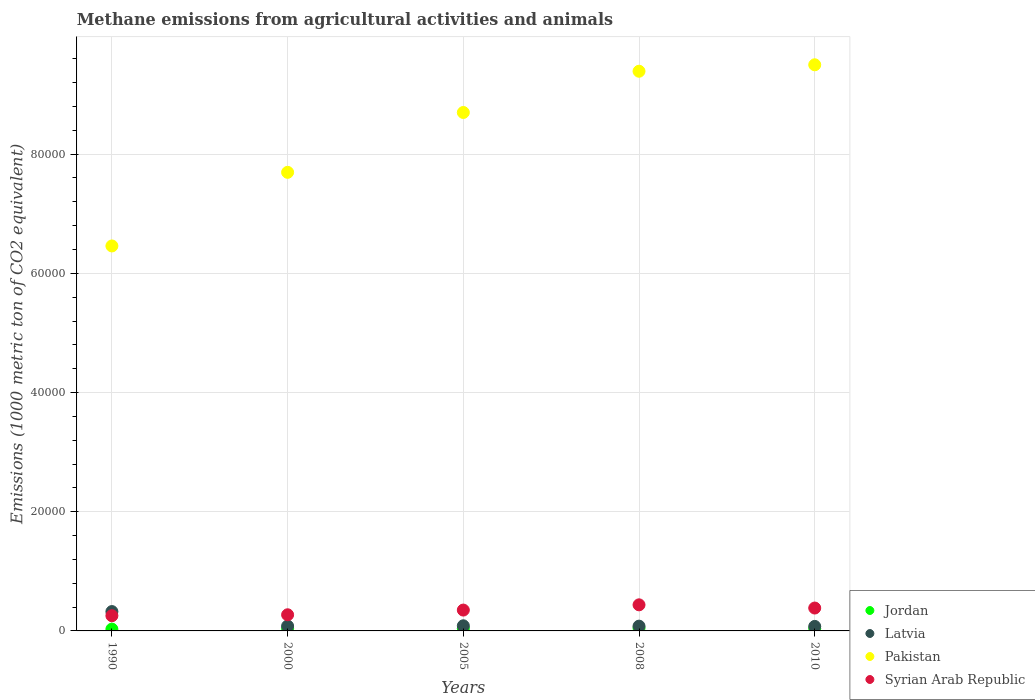How many different coloured dotlines are there?
Offer a terse response. 4. Is the number of dotlines equal to the number of legend labels?
Provide a short and direct response. Yes. What is the amount of methane emitted in Pakistan in 1990?
Your answer should be very brief. 6.46e+04. Across all years, what is the maximum amount of methane emitted in Latvia?
Your answer should be compact. 3247.8. Across all years, what is the minimum amount of methane emitted in Syrian Arab Republic?
Your response must be concise. 2551.7. In which year was the amount of methane emitted in Syrian Arab Republic maximum?
Offer a terse response. 2008. In which year was the amount of methane emitted in Pakistan minimum?
Your answer should be very brief. 1990. What is the total amount of methane emitted in Latvia in the graph?
Your answer should be compact. 6479.7. What is the difference between the amount of methane emitted in Latvia in 1990 and that in 2010?
Your response must be concise. 2491.9. What is the difference between the amount of methane emitted in Jordan in 2000 and the amount of methane emitted in Pakistan in 2010?
Make the answer very short. -9.46e+04. What is the average amount of methane emitted in Syrian Arab Republic per year?
Your answer should be compact. 3395.08. In the year 2010, what is the difference between the amount of methane emitted in Latvia and amount of methane emitted in Jordan?
Your answer should be compact. 358.3. What is the ratio of the amount of methane emitted in Syrian Arab Republic in 1990 to that in 2010?
Your answer should be very brief. 0.66. Is the amount of methane emitted in Pakistan in 2005 less than that in 2008?
Give a very brief answer. Yes. What is the difference between the highest and the second highest amount of methane emitted in Pakistan?
Keep it short and to the point. 1082. What is the difference between the highest and the lowest amount of methane emitted in Jordan?
Make the answer very short. 167.1. In how many years, is the amount of methane emitted in Latvia greater than the average amount of methane emitted in Latvia taken over all years?
Offer a very short reply. 1. Is the sum of the amount of methane emitted in Jordan in 2005 and 2008 greater than the maximum amount of methane emitted in Syrian Arab Republic across all years?
Your response must be concise. No. Is it the case that in every year, the sum of the amount of methane emitted in Syrian Arab Republic and amount of methane emitted in Latvia  is greater than the sum of amount of methane emitted in Jordan and amount of methane emitted in Pakistan?
Offer a very short reply. Yes. Does the amount of methane emitted in Latvia monotonically increase over the years?
Your answer should be compact. No. How many dotlines are there?
Offer a terse response. 4. Are the values on the major ticks of Y-axis written in scientific E-notation?
Provide a short and direct response. No. Does the graph contain grids?
Offer a terse response. Yes. How many legend labels are there?
Provide a succinct answer. 4. What is the title of the graph?
Your response must be concise. Methane emissions from agricultural activities and animals. Does "Uganda" appear as one of the legend labels in the graph?
Make the answer very short. No. What is the label or title of the X-axis?
Your response must be concise. Years. What is the label or title of the Y-axis?
Give a very brief answer. Emissions (1000 metric ton of CO2 equivalent). What is the Emissions (1000 metric ton of CO2 equivalent) of Jordan in 1990?
Ensure brevity in your answer.  303.3. What is the Emissions (1000 metric ton of CO2 equivalent) in Latvia in 1990?
Your response must be concise. 3247.8. What is the Emissions (1000 metric ton of CO2 equivalent) in Pakistan in 1990?
Offer a very short reply. 6.46e+04. What is the Emissions (1000 metric ton of CO2 equivalent) in Syrian Arab Republic in 1990?
Provide a succinct answer. 2551.7. What is the Emissions (1000 metric ton of CO2 equivalent) in Jordan in 2000?
Provide a succinct answer. 374. What is the Emissions (1000 metric ton of CO2 equivalent) of Latvia in 2000?
Make the answer very short. 814.5. What is the Emissions (1000 metric ton of CO2 equivalent) in Pakistan in 2000?
Ensure brevity in your answer.  7.69e+04. What is the Emissions (1000 metric ton of CO2 equivalent) in Syrian Arab Republic in 2000?
Ensure brevity in your answer.  2708.8. What is the Emissions (1000 metric ton of CO2 equivalent) in Jordan in 2005?
Your answer should be very brief. 391.8. What is the Emissions (1000 metric ton of CO2 equivalent) in Latvia in 2005?
Ensure brevity in your answer.  860.7. What is the Emissions (1000 metric ton of CO2 equivalent) in Pakistan in 2005?
Ensure brevity in your answer.  8.70e+04. What is the Emissions (1000 metric ton of CO2 equivalent) of Syrian Arab Republic in 2005?
Offer a terse response. 3498.3. What is the Emissions (1000 metric ton of CO2 equivalent) of Jordan in 2008?
Provide a succinct answer. 470.4. What is the Emissions (1000 metric ton of CO2 equivalent) of Latvia in 2008?
Your answer should be compact. 800.8. What is the Emissions (1000 metric ton of CO2 equivalent) of Pakistan in 2008?
Keep it short and to the point. 9.39e+04. What is the Emissions (1000 metric ton of CO2 equivalent) in Syrian Arab Republic in 2008?
Make the answer very short. 4376.8. What is the Emissions (1000 metric ton of CO2 equivalent) of Jordan in 2010?
Offer a very short reply. 397.6. What is the Emissions (1000 metric ton of CO2 equivalent) in Latvia in 2010?
Your response must be concise. 755.9. What is the Emissions (1000 metric ton of CO2 equivalent) of Pakistan in 2010?
Ensure brevity in your answer.  9.50e+04. What is the Emissions (1000 metric ton of CO2 equivalent) of Syrian Arab Republic in 2010?
Provide a succinct answer. 3839.8. Across all years, what is the maximum Emissions (1000 metric ton of CO2 equivalent) of Jordan?
Your answer should be compact. 470.4. Across all years, what is the maximum Emissions (1000 metric ton of CO2 equivalent) of Latvia?
Your response must be concise. 3247.8. Across all years, what is the maximum Emissions (1000 metric ton of CO2 equivalent) of Pakistan?
Keep it short and to the point. 9.50e+04. Across all years, what is the maximum Emissions (1000 metric ton of CO2 equivalent) in Syrian Arab Republic?
Offer a terse response. 4376.8. Across all years, what is the minimum Emissions (1000 metric ton of CO2 equivalent) of Jordan?
Your response must be concise. 303.3. Across all years, what is the minimum Emissions (1000 metric ton of CO2 equivalent) of Latvia?
Ensure brevity in your answer.  755.9. Across all years, what is the minimum Emissions (1000 metric ton of CO2 equivalent) in Pakistan?
Your response must be concise. 6.46e+04. Across all years, what is the minimum Emissions (1000 metric ton of CO2 equivalent) in Syrian Arab Republic?
Your response must be concise. 2551.7. What is the total Emissions (1000 metric ton of CO2 equivalent) in Jordan in the graph?
Your answer should be very brief. 1937.1. What is the total Emissions (1000 metric ton of CO2 equivalent) in Latvia in the graph?
Your answer should be very brief. 6479.7. What is the total Emissions (1000 metric ton of CO2 equivalent) in Pakistan in the graph?
Give a very brief answer. 4.17e+05. What is the total Emissions (1000 metric ton of CO2 equivalent) in Syrian Arab Republic in the graph?
Your answer should be compact. 1.70e+04. What is the difference between the Emissions (1000 metric ton of CO2 equivalent) of Jordan in 1990 and that in 2000?
Offer a very short reply. -70.7. What is the difference between the Emissions (1000 metric ton of CO2 equivalent) of Latvia in 1990 and that in 2000?
Provide a succinct answer. 2433.3. What is the difference between the Emissions (1000 metric ton of CO2 equivalent) of Pakistan in 1990 and that in 2000?
Your answer should be compact. -1.24e+04. What is the difference between the Emissions (1000 metric ton of CO2 equivalent) of Syrian Arab Republic in 1990 and that in 2000?
Provide a short and direct response. -157.1. What is the difference between the Emissions (1000 metric ton of CO2 equivalent) in Jordan in 1990 and that in 2005?
Provide a succinct answer. -88.5. What is the difference between the Emissions (1000 metric ton of CO2 equivalent) of Latvia in 1990 and that in 2005?
Give a very brief answer. 2387.1. What is the difference between the Emissions (1000 metric ton of CO2 equivalent) of Pakistan in 1990 and that in 2005?
Make the answer very short. -2.24e+04. What is the difference between the Emissions (1000 metric ton of CO2 equivalent) in Syrian Arab Republic in 1990 and that in 2005?
Provide a succinct answer. -946.6. What is the difference between the Emissions (1000 metric ton of CO2 equivalent) of Jordan in 1990 and that in 2008?
Offer a very short reply. -167.1. What is the difference between the Emissions (1000 metric ton of CO2 equivalent) of Latvia in 1990 and that in 2008?
Provide a short and direct response. 2447. What is the difference between the Emissions (1000 metric ton of CO2 equivalent) in Pakistan in 1990 and that in 2008?
Provide a succinct answer. -2.93e+04. What is the difference between the Emissions (1000 metric ton of CO2 equivalent) in Syrian Arab Republic in 1990 and that in 2008?
Your answer should be compact. -1825.1. What is the difference between the Emissions (1000 metric ton of CO2 equivalent) of Jordan in 1990 and that in 2010?
Provide a short and direct response. -94.3. What is the difference between the Emissions (1000 metric ton of CO2 equivalent) in Latvia in 1990 and that in 2010?
Make the answer very short. 2491.9. What is the difference between the Emissions (1000 metric ton of CO2 equivalent) in Pakistan in 1990 and that in 2010?
Ensure brevity in your answer.  -3.04e+04. What is the difference between the Emissions (1000 metric ton of CO2 equivalent) in Syrian Arab Republic in 1990 and that in 2010?
Keep it short and to the point. -1288.1. What is the difference between the Emissions (1000 metric ton of CO2 equivalent) in Jordan in 2000 and that in 2005?
Provide a succinct answer. -17.8. What is the difference between the Emissions (1000 metric ton of CO2 equivalent) of Latvia in 2000 and that in 2005?
Your answer should be very brief. -46.2. What is the difference between the Emissions (1000 metric ton of CO2 equivalent) in Pakistan in 2000 and that in 2005?
Ensure brevity in your answer.  -1.00e+04. What is the difference between the Emissions (1000 metric ton of CO2 equivalent) of Syrian Arab Republic in 2000 and that in 2005?
Your response must be concise. -789.5. What is the difference between the Emissions (1000 metric ton of CO2 equivalent) in Jordan in 2000 and that in 2008?
Provide a succinct answer. -96.4. What is the difference between the Emissions (1000 metric ton of CO2 equivalent) in Latvia in 2000 and that in 2008?
Your response must be concise. 13.7. What is the difference between the Emissions (1000 metric ton of CO2 equivalent) of Pakistan in 2000 and that in 2008?
Offer a very short reply. -1.70e+04. What is the difference between the Emissions (1000 metric ton of CO2 equivalent) of Syrian Arab Republic in 2000 and that in 2008?
Offer a terse response. -1668. What is the difference between the Emissions (1000 metric ton of CO2 equivalent) in Jordan in 2000 and that in 2010?
Ensure brevity in your answer.  -23.6. What is the difference between the Emissions (1000 metric ton of CO2 equivalent) of Latvia in 2000 and that in 2010?
Your answer should be very brief. 58.6. What is the difference between the Emissions (1000 metric ton of CO2 equivalent) of Pakistan in 2000 and that in 2010?
Your response must be concise. -1.80e+04. What is the difference between the Emissions (1000 metric ton of CO2 equivalent) of Syrian Arab Republic in 2000 and that in 2010?
Ensure brevity in your answer.  -1131. What is the difference between the Emissions (1000 metric ton of CO2 equivalent) in Jordan in 2005 and that in 2008?
Offer a terse response. -78.6. What is the difference between the Emissions (1000 metric ton of CO2 equivalent) in Latvia in 2005 and that in 2008?
Keep it short and to the point. 59.9. What is the difference between the Emissions (1000 metric ton of CO2 equivalent) of Pakistan in 2005 and that in 2008?
Provide a succinct answer. -6920.4. What is the difference between the Emissions (1000 metric ton of CO2 equivalent) of Syrian Arab Republic in 2005 and that in 2008?
Your answer should be compact. -878.5. What is the difference between the Emissions (1000 metric ton of CO2 equivalent) of Latvia in 2005 and that in 2010?
Your answer should be very brief. 104.8. What is the difference between the Emissions (1000 metric ton of CO2 equivalent) in Pakistan in 2005 and that in 2010?
Offer a terse response. -8002.4. What is the difference between the Emissions (1000 metric ton of CO2 equivalent) of Syrian Arab Republic in 2005 and that in 2010?
Ensure brevity in your answer.  -341.5. What is the difference between the Emissions (1000 metric ton of CO2 equivalent) in Jordan in 2008 and that in 2010?
Give a very brief answer. 72.8. What is the difference between the Emissions (1000 metric ton of CO2 equivalent) of Latvia in 2008 and that in 2010?
Offer a very short reply. 44.9. What is the difference between the Emissions (1000 metric ton of CO2 equivalent) in Pakistan in 2008 and that in 2010?
Give a very brief answer. -1082. What is the difference between the Emissions (1000 metric ton of CO2 equivalent) in Syrian Arab Republic in 2008 and that in 2010?
Offer a very short reply. 537. What is the difference between the Emissions (1000 metric ton of CO2 equivalent) in Jordan in 1990 and the Emissions (1000 metric ton of CO2 equivalent) in Latvia in 2000?
Your answer should be compact. -511.2. What is the difference between the Emissions (1000 metric ton of CO2 equivalent) of Jordan in 1990 and the Emissions (1000 metric ton of CO2 equivalent) of Pakistan in 2000?
Your answer should be compact. -7.66e+04. What is the difference between the Emissions (1000 metric ton of CO2 equivalent) in Jordan in 1990 and the Emissions (1000 metric ton of CO2 equivalent) in Syrian Arab Republic in 2000?
Provide a short and direct response. -2405.5. What is the difference between the Emissions (1000 metric ton of CO2 equivalent) in Latvia in 1990 and the Emissions (1000 metric ton of CO2 equivalent) in Pakistan in 2000?
Offer a very short reply. -7.37e+04. What is the difference between the Emissions (1000 metric ton of CO2 equivalent) in Latvia in 1990 and the Emissions (1000 metric ton of CO2 equivalent) in Syrian Arab Republic in 2000?
Provide a short and direct response. 539. What is the difference between the Emissions (1000 metric ton of CO2 equivalent) of Pakistan in 1990 and the Emissions (1000 metric ton of CO2 equivalent) of Syrian Arab Republic in 2000?
Ensure brevity in your answer.  6.19e+04. What is the difference between the Emissions (1000 metric ton of CO2 equivalent) of Jordan in 1990 and the Emissions (1000 metric ton of CO2 equivalent) of Latvia in 2005?
Keep it short and to the point. -557.4. What is the difference between the Emissions (1000 metric ton of CO2 equivalent) in Jordan in 1990 and the Emissions (1000 metric ton of CO2 equivalent) in Pakistan in 2005?
Ensure brevity in your answer.  -8.67e+04. What is the difference between the Emissions (1000 metric ton of CO2 equivalent) of Jordan in 1990 and the Emissions (1000 metric ton of CO2 equivalent) of Syrian Arab Republic in 2005?
Your answer should be very brief. -3195. What is the difference between the Emissions (1000 metric ton of CO2 equivalent) in Latvia in 1990 and the Emissions (1000 metric ton of CO2 equivalent) in Pakistan in 2005?
Provide a succinct answer. -8.37e+04. What is the difference between the Emissions (1000 metric ton of CO2 equivalent) in Latvia in 1990 and the Emissions (1000 metric ton of CO2 equivalent) in Syrian Arab Republic in 2005?
Your response must be concise. -250.5. What is the difference between the Emissions (1000 metric ton of CO2 equivalent) in Pakistan in 1990 and the Emissions (1000 metric ton of CO2 equivalent) in Syrian Arab Republic in 2005?
Your response must be concise. 6.11e+04. What is the difference between the Emissions (1000 metric ton of CO2 equivalent) in Jordan in 1990 and the Emissions (1000 metric ton of CO2 equivalent) in Latvia in 2008?
Make the answer very short. -497.5. What is the difference between the Emissions (1000 metric ton of CO2 equivalent) of Jordan in 1990 and the Emissions (1000 metric ton of CO2 equivalent) of Pakistan in 2008?
Your answer should be compact. -9.36e+04. What is the difference between the Emissions (1000 metric ton of CO2 equivalent) of Jordan in 1990 and the Emissions (1000 metric ton of CO2 equivalent) of Syrian Arab Republic in 2008?
Offer a very short reply. -4073.5. What is the difference between the Emissions (1000 metric ton of CO2 equivalent) of Latvia in 1990 and the Emissions (1000 metric ton of CO2 equivalent) of Pakistan in 2008?
Offer a terse response. -9.07e+04. What is the difference between the Emissions (1000 metric ton of CO2 equivalent) of Latvia in 1990 and the Emissions (1000 metric ton of CO2 equivalent) of Syrian Arab Republic in 2008?
Keep it short and to the point. -1129. What is the difference between the Emissions (1000 metric ton of CO2 equivalent) in Pakistan in 1990 and the Emissions (1000 metric ton of CO2 equivalent) in Syrian Arab Republic in 2008?
Keep it short and to the point. 6.02e+04. What is the difference between the Emissions (1000 metric ton of CO2 equivalent) of Jordan in 1990 and the Emissions (1000 metric ton of CO2 equivalent) of Latvia in 2010?
Make the answer very short. -452.6. What is the difference between the Emissions (1000 metric ton of CO2 equivalent) of Jordan in 1990 and the Emissions (1000 metric ton of CO2 equivalent) of Pakistan in 2010?
Offer a very short reply. -9.47e+04. What is the difference between the Emissions (1000 metric ton of CO2 equivalent) in Jordan in 1990 and the Emissions (1000 metric ton of CO2 equivalent) in Syrian Arab Republic in 2010?
Your answer should be very brief. -3536.5. What is the difference between the Emissions (1000 metric ton of CO2 equivalent) of Latvia in 1990 and the Emissions (1000 metric ton of CO2 equivalent) of Pakistan in 2010?
Your response must be concise. -9.17e+04. What is the difference between the Emissions (1000 metric ton of CO2 equivalent) in Latvia in 1990 and the Emissions (1000 metric ton of CO2 equivalent) in Syrian Arab Republic in 2010?
Your answer should be very brief. -592. What is the difference between the Emissions (1000 metric ton of CO2 equivalent) in Pakistan in 1990 and the Emissions (1000 metric ton of CO2 equivalent) in Syrian Arab Republic in 2010?
Your answer should be very brief. 6.08e+04. What is the difference between the Emissions (1000 metric ton of CO2 equivalent) of Jordan in 2000 and the Emissions (1000 metric ton of CO2 equivalent) of Latvia in 2005?
Offer a very short reply. -486.7. What is the difference between the Emissions (1000 metric ton of CO2 equivalent) in Jordan in 2000 and the Emissions (1000 metric ton of CO2 equivalent) in Pakistan in 2005?
Your answer should be compact. -8.66e+04. What is the difference between the Emissions (1000 metric ton of CO2 equivalent) of Jordan in 2000 and the Emissions (1000 metric ton of CO2 equivalent) of Syrian Arab Republic in 2005?
Offer a terse response. -3124.3. What is the difference between the Emissions (1000 metric ton of CO2 equivalent) in Latvia in 2000 and the Emissions (1000 metric ton of CO2 equivalent) in Pakistan in 2005?
Your answer should be very brief. -8.62e+04. What is the difference between the Emissions (1000 metric ton of CO2 equivalent) of Latvia in 2000 and the Emissions (1000 metric ton of CO2 equivalent) of Syrian Arab Republic in 2005?
Your answer should be compact. -2683.8. What is the difference between the Emissions (1000 metric ton of CO2 equivalent) in Pakistan in 2000 and the Emissions (1000 metric ton of CO2 equivalent) in Syrian Arab Republic in 2005?
Offer a very short reply. 7.34e+04. What is the difference between the Emissions (1000 metric ton of CO2 equivalent) in Jordan in 2000 and the Emissions (1000 metric ton of CO2 equivalent) in Latvia in 2008?
Give a very brief answer. -426.8. What is the difference between the Emissions (1000 metric ton of CO2 equivalent) in Jordan in 2000 and the Emissions (1000 metric ton of CO2 equivalent) in Pakistan in 2008?
Provide a short and direct response. -9.35e+04. What is the difference between the Emissions (1000 metric ton of CO2 equivalent) of Jordan in 2000 and the Emissions (1000 metric ton of CO2 equivalent) of Syrian Arab Republic in 2008?
Make the answer very short. -4002.8. What is the difference between the Emissions (1000 metric ton of CO2 equivalent) of Latvia in 2000 and the Emissions (1000 metric ton of CO2 equivalent) of Pakistan in 2008?
Offer a very short reply. -9.31e+04. What is the difference between the Emissions (1000 metric ton of CO2 equivalent) in Latvia in 2000 and the Emissions (1000 metric ton of CO2 equivalent) in Syrian Arab Republic in 2008?
Provide a short and direct response. -3562.3. What is the difference between the Emissions (1000 metric ton of CO2 equivalent) of Pakistan in 2000 and the Emissions (1000 metric ton of CO2 equivalent) of Syrian Arab Republic in 2008?
Make the answer very short. 7.26e+04. What is the difference between the Emissions (1000 metric ton of CO2 equivalent) of Jordan in 2000 and the Emissions (1000 metric ton of CO2 equivalent) of Latvia in 2010?
Keep it short and to the point. -381.9. What is the difference between the Emissions (1000 metric ton of CO2 equivalent) in Jordan in 2000 and the Emissions (1000 metric ton of CO2 equivalent) in Pakistan in 2010?
Give a very brief answer. -9.46e+04. What is the difference between the Emissions (1000 metric ton of CO2 equivalent) of Jordan in 2000 and the Emissions (1000 metric ton of CO2 equivalent) of Syrian Arab Republic in 2010?
Your answer should be compact. -3465.8. What is the difference between the Emissions (1000 metric ton of CO2 equivalent) of Latvia in 2000 and the Emissions (1000 metric ton of CO2 equivalent) of Pakistan in 2010?
Ensure brevity in your answer.  -9.42e+04. What is the difference between the Emissions (1000 metric ton of CO2 equivalent) of Latvia in 2000 and the Emissions (1000 metric ton of CO2 equivalent) of Syrian Arab Republic in 2010?
Give a very brief answer. -3025.3. What is the difference between the Emissions (1000 metric ton of CO2 equivalent) of Pakistan in 2000 and the Emissions (1000 metric ton of CO2 equivalent) of Syrian Arab Republic in 2010?
Keep it short and to the point. 7.31e+04. What is the difference between the Emissions (1000 metric ton of CO2 equivalent) in Jordan in 2005 and the Emissions (1000 metric ton of CO2 equivalent) in Latvia in 2008?
Ensure brevity in your answer.  -409. What is the difference between the Emissions (1000 metric ton of CO2 equivalent) of Jordan in 2005 and the Emissions (1000 metric ton of CO2 equivalent) of Pakistan in 2008?
Provide a succinct answer. -9.35e+04. What is the difference between the Emissions (1000 metric ton of CO2 equivalent) in Jordan in 2005 and the Emissions (1000 metric ton of CO2 equivalent) in Syrian Arab Republic in 2008?
Your answer should be compact. -3985. What is the difference between the Emissions (1000 metric ton of CO2 equivalent) of Latvia in 2005 and the Emissions (1000 metric ton of CO2 equivalent) of Pakistan in 2008?
Provide a succinct answer. -9.30e+04. What is the difference between the Emissions (1000 metric ton of CO2 equivalent) of Latvia in 2005 and the Emissions (1000 metric ton of CO2 equivalent) of Syrian Arab Republic in 2008?
Keep it short and to the point. -3516.1. What is the difference between the Emissions (1000 metric ton of CO2 equivalent) of Pakistan in 2005 and the Emissions (1000 metric ton of CO2 equivalent) of Syrian Arab Republic in 2008?
Offer a terse response. 8.26e+04. What is the difference between the Emissions (1000 metric ton of CO2 equivalent) of Jordan in 2005 and the Emissions (1000 metric ton of CO2 equivalent) of Latvia in 2010?
Offer a very short reply. -364.1. What is the difference between the Emissions (1000 metric ton of CO2 equivalent) of Jordan in 2005 and the Emissions (1000 metric ton of CO2 equivalent) of Pakistan in 2010?
Make the answer very short. -9.46e+04. What is the difference between the Emissions (1000 metric ton of CO2 equivalent) of Jordan in 2005 and the Emissions (1000 metric ton of CO2 equivalent) of Syrian Arab Republic in 2010?
Keep it short and to the point. -3448. What is the difference between the Emissions (1000 metric ton of CO2 equivalent) of Latvia in 2005 and the Emissions (1000 metric ton of CO2 equivalent) of Pakistan in 2010?
Keep it short and to the point. -9.41e+04. What is the difference between the Emissions (1000 metric ton of CO2 equivalent) of Latvia in 2005 and the Emissions (1000 metric ton of CO2 equivalent) of Syrian Arab Republic in 2010?
Provide a succinct answer. -2979.1. What is the difference between the Emissions (1000 metric ton of CO2 equivalent) of Pakistan in 2005 and the Emissions (1000 metric ton of CO2 equivalent) of Syrian Arab Republic in 2010?
Ensure brevity in your answer.  8.31e+04. What is the difference between the Emissions (1000 metric ton of CO2 equivalent) in Jordan in 2008 and the Emissions (1000 metric ton of CO2 equivalent) in Latvia in 2010?
Your answer should be very brief. -285.5. What is the difference between the Emissions (1000 metric ton of CO2 equivalent) of Jordan in 2008 and the Emissions (1000 metric ton of CO2 equivalent) of Pakistan in 2010?
Provide a short and direct response. -9.45e+04. What is the difference between the Emissions (1000 metric ton of CO2 equivalent) of Jordan in 2008 and the Emissions (1000 metric ton of CO2 equivalent) of Syrian Arab Republic in 2010?
Ensure brevity in your answer.  -3369.4. What is the difference between the Emissions (1000 metric ton of CO2 equivalent) of Latvia in 2008 and the Emissions (1000 metric ton of CO2 equivalent) of Pakistan in 2010?
Your answer should be very brief. -9.42e+04. What is the difference between the Emissions (1000 metric ton of CO2 equivalent) of Latvia in 2008 and the Emissions (1000 metric ton of CO2 equivalent) of Syrian Arab Republic in 2010?
Your answer should be compact. -3039. What is the difference between the Emissions (1000 metric ton of CO2 equivalent) of Pakistan in 2008 and the Emissions (1000 metric ton of CO2 equivalent) of Syrian Arab Republic in 2010?
Give a very brief answer. 9.01e+04. What is the average Emissions (1000 metric ton of CO2 equivalent) of Jordan per year?
Offer a very short reply. 387.42. What is the average Emissions (1000 metric ton of CO2 equivalent) in Latvia per year?
Provide a short and direct response. 1295.94. What is the average Emissions (1000 metric ton of CO2 equivalent) in Pakistan per year?
Offer a terse response. 8.35e+04. What is the average Emissions (1000 metric ton of CO2 equivalent) in Syrian Arab Republic per year?
Offer a very short reply. 3395.08. In the year 1990, what is the difference between the Emissions (1000 metric ton of CO2 equivalent) of Jordan and Emissions (1000 metric ton of CO2 equivalent) of Latvia?
Make the answer very short. -2944.5. In the year 1990, what is the difference between the Emissions (1000 metric ton of CO2 equivalent) of Jordan and Emissions (1000 metric ton of CO2 equivalent) of Pakistan?
Offer a terse response. -6.43e+04. In the year 1990, what is the difference between the Emissions (1000 metric ton of CO2 equivalent) of Jordan and Emissions (1000 metric ton of CO2 equivalent) of Syrian Arab Republic?
Provide a short and direct response. -2248.4. In the year 1990, what is the difference between the Emissions (1000 metric ton of CO2 equivalent) of Latvia and Emissions (1000 metric ton of CO2 equivalent) of Pakistan?
Your answer should be compact. -6.13e+04. In the year 1990, what is the difference between the Emissions (1000 metric ton of CO2 equivalent) of Latvia and Emissions (1000 metric ton of CO2 equivalent) of Syrian Arab Republic?
Provide a short and direct response. 696.1. In the year 1990, what is the difference between the Emissions (1000 metric ton of CO2 equivalent) of Pakistan and Emissions (1000 metric ton of CO2 equivalent) of Syrian Arab Republic?
Keep it short and to the point. 6.20e+04. In the year 2000, what is the difference between the Emissions (1000 metric ton of CO2 equivalent) in Jordan and Emissions (1000 metric ton of CO2 equivalent) in Latvia?
Offer a very short reply. -440.5. In the year 2000, what is the difference between the Emissions (1000 metric ton of CO2 equivalent) in Jordan and Emissions (1000 metric ton of CO2 equivalent) in Pakistan?
Offer a terse response. -7.66e+04. In the year 2000, what is the difference between the Emissions (1000 metric ton of CO2 equivalent) in Jordan and Emissions (1000 metric ton of CO2 equivalent) in Syrian Arab Republic?
Your response must be concise. -2334.8. In the year 2000, what is the difference between the Emissions (1000 metric ton of CO2 equivalent) of Latvia and Emissions (1000 metric ton of CO2 equivalent) of Pakistan?
Offer a very short reply. -7.61e+04. In the year 2000, what is the difference between the Emissions (1000 metric ton of CO2 equivalent) in Latvia and Emissions (1000 metric ton of CO2 equivalent) in Syrian Arab Republic?
Your answer should be compact. -1894.3. In the year 2000, what is the difference between the Emissions (1000 metric ton of CO2 equivalent) of Pakistan and Emissions (1000 metric ton of CO2 equivalent) of Syrian Arab Republic?
Provide a succinct answer. 7.42e+04. In the year 2005, what is the difference between the Emissions (1000 metric ton of CO2 equivalent) in Jordan and Emissions (1000 metric ton of CO2 equivalent) in Latvia?
Make the answer very short. -468.9. In the year 2005, what is the difference between the Emissions (1000 metric ton of CO2 equivalent) of Jordan and Emissions (1000 metric ton of CO2 equivalent) of Pakistan?
Make the answer very short. -8.66e+04. In the year 2005, what is the difference between the Emissions (1000 metric ton of CO2 equivalent) in Jordan and Emissions (1000 metric ton of CO2 equivalent) in Syrian Arab Republic?
Provide a succinct answer. -3106.5. In the year 2005, what is the difference between the Emissions (1000 metric ton of CO2 equivalent) in Latvia and Emissions (1000 metric ton of CO2 equivalent) in Pakistan?
Ensure brevity in your answer.  -8.61e+04. In the year 2005, what is the difference between the Emissions (1000 metric ton of CO2 equivalent) of Latvia and Emissions (1000 metric ton of CO2 equivalent) of Syrian Arab Republic?
Ensure brevity in your answer.  -2637.6. In the year 2005, what is the difference between the Emissions (1000 metric ton of CO2 equivalent) of Pakistan and Emissions (1000 metric ton of CO2 equivalent) of Syrian Arab Republic?
Ensure brevity in your answer.  8.35e+04. In the year 2008, what is the difference between the Emissions (1000 metric ton of CO2 equivalent) of Jordan and Emissions (1000 metric ton of CO2 equivalent) of Latvia?
Give a very brief answer. -330.4. In the year 2008, what is the difference between the Emissions (1000 metric ton of CO2 equivalent) in Jordan and Emissions (1000 metric ton of CO2 equivalent) in Pakistan?
Provide a succinct answer. -9.34e+04. In the year 2008, what is the difference between the Emissions (1000 metric ton of CO2 equivalent) in Jordan and Emissions (1000 metric ton of CO2 equivalent) in Syrian Arab Republic?
Provide a succinct answer. -3906.4. In the year 2008, what is the difference between the Emissions (1000 metric ton of CO2 equivalent) in Latvia and Emissions (1000 metric ton of CO2 equivalent) in Pakistan?
Offer a terse response. -9.31e+04. In the year 2008, what is the difference between the Emissions (1000 metric ton of CO2 equivalent) in Latvia and Emissions (1000 metric ton of CO2 equivalent) in Syrian Arab Republic?
Offer a very short reply. -3576. In the year 2008, what is the difference between the Emissions (1000 metric ton of CO2 equivalent) of Pakistan and Emissions (1000 metric ton of CO2 equivalent) of Syrian Arab Republic?
Your answer should be compact. 8.95e+04. In the year 2010, what is the difference between the Emissions (1000 metric ton of CO2 equivalent) in Jordan and Emissions (1000 metric ton of CO2 equivalent) in Latvia?
Your answer should be very brief. -358.3. In the year 2010, what is the difference between the Emissions (1000 metric ton of CO2 equivalent) of Jordan and Emissions (1000 metric ton of CO2 equivalent) of Pakistan?
Give a very brief answer. -9.46e+04. In the year 2010, what is the difference between the Emissions (1000 metric ton of CO2 equivalent) of Jordan and Emissions (1000 metric ton of CO2 equivalent) of Syrian Arab Republic?
Your response must be concise. -3442.2. In the year 2010, what is the difference between the Emissions (1000 metric ton of CO2 equivalent) in Latvia and Emissions (1000 metric ton of CO2 equivalent) in Pakistan?
Offer a very short reply. -9.42e+04. In the year 2010, what is the difference between the Emissions (1000 metric ton of CO2 equivalent) in Latvia and Emissions (1000 metric ton of CO2 equivalent) in Syrian Arab Republic?
Your response must be concise. -3083.9. In the year 2010, what is the difference between the Emissions (1000 metric ton of CO2 equivalent) in Pakistan and Emissions (1000 metric ton of CO2 equivalent) in Syrian Arab Republic?
Offer a very short reply. 9.11e+04. What is the ratio of the Emissions (1000 metric ton of CO2 equivalent) in Jordan in 1990 to that in 2000?
Your answer should be compact. 0.81. What is the ratio of the Emissions (1000 metric ton of CO2 equivalent) in Latvia in 1990 to that in 2000?
Ensure brevity in your answer.  3.99. What is the ratio of the Emissions (1000 metric ton of CO2 equivalent) of Pakistan in 1990 to that in 2000?
Provide a succinct answer. 0.84. What is the ratio of the Emissions (1000 metric ton of CO2 equivalent) in Syrian Arab Republic in 1990 to that in 2000?
Ensure brevity in your answer.  0.94. What is the ratio of the Emissions (1000 metric ton of CO2 equivalent) of Jordan in 1990 to that in 2005?
Give a very brief answer. 0.77. What is the ratio of the Emissions (1000 metric ton of CO2 equivalent) of Latvia in 1990 to that in 2005?
Keep it short and to the point. 3.77. What is the ratio of the Emissions (1000 metric ton of CO2 equivalent) of Pakistan in 1990 to that in 2005?
Provide a short and direct response. 0.74. What is the ratio of the Emissions (1000 metric ton of CO2 equivalent) in Syrian Arab Republic in 1990 to that in 2005?
Make the answer very short. 0.73. What is the ratio of the Emissions (1000 metric ton of CO2 equivalent) of Jordan in 1990 to that in 2008?
Give a very brief answer. 0.64. What is the ratio of the Emissions (1000 metric ton of CO2 equivalent) of Latvia in 1990 to that in 2008?
Make the answer very short. 4.06. What is the ratio of the Emissions (1000 metric ton of CO2 equivalent) of Pakistan in 1990 to that in 2008?
Keep it short and to the point. 0.69. What is the ratio of the Emissions (1000 metric ton of CO2 equivalent) of Syrian Arab Republic in 1990 to that in 2008?
Ensure brevity in your answer.  0.58. What is the ratio of the Emissions (1000 metric ton of CO2 equivalent) of Jordan in 1990 to that in 2010?
Provide a succinct answer. 0.76. What is the ratio of the Emissions (1000 metric ton of CO2 equivalent) of Latvia in 1990 to that in 2010?
Ensure brevity in your answer.  4.3. What is the ratio of the Emissions (1000 metric ton of CO2 equivalent) of Pakistan in 1990 to that in 2010?
Your answer should be very brief. 0.68. What is the ratio of the Emissions (1000 metric ton of CO2 equivalent) in Syrian Arab Republic in 1990 to that in 2010?
Your answer should be very brief. 0.66. What is the ratio of the Emissions (1000 metric ton of CO2 equivalent) in Jordan in 2000 to that in 2005?
Provide a short and direct response. 0.95. What is the ratio of the Emissions (1000 metric ton of CO2 equivalent) in Latvia in 2000 to that in 2005?
Ensure brevity in your answer.  0.95. What is the ratio of the Emissions (1000 metric ton of CO2 equivalent) of Pakistan in 2000 to that in 2005?
Offer a very short reply. 0.88. What is the ratio of the Emissions (1000 metric ton of CO2 equivalent) of Syrian Arab Republic in 2000 to that in 2005?
Provide a short and direct response. 0.77. What is the ratio of the Emissions (1000 metric ton of CO2 equivalent) of Jordan in 2000 to that in 2008?
Your answer should be very brief. 0.8. What is the ratio of the Emissions (1000 metric ton of CO2 equivalent) in Latvia in 2000 to that in 2008?
Provide a short and direct response. 1.02. What is the ratio of the Emissions (1000 metric ton of CO2 equivalent) in Pakistan in 2000 to that in 2008?
Make the answer very short. 0.82. What is the ratio of the Emissions (1000 metric ton of CO2 equivalent) in Syrian Arab Republic in 2000 to that in 2008?
Your answer should be compact. 0.62. What is the ratio of the Emissions (1000 metric ton of CO2 equivalent) in Jordan in 2000 to that in 2010?
Provide a succinct answer. 0.94. What is the ratio of the Emissions (1000 metric ton of CO2 equivalent) of Latvia in 2000 to that in 2010?
Your response must be concise. 1.08. What is the ratio of the Emissions (1000 metric ton of CO2 equivalent) of Pakistan in 2000 to that in 2010?
Your answer should be compact. 0.81. What is the ratio of the Emissions (1000 metric ton of CO2 equivalent) in Syrian Arab Republic in 2000 to that in 2010?
Your answer should be very brief. 0.71. What is the ratio of the Emissions (1000 metric ton of CO2 equivalent) of Jordan in 2005 to that in 2008?
Give a very brief answer. 0.83. What is the ratio of the Emissions (1000 metric ton of CO2 equivalent) in Latvia in 2005 to that in 2008?
Ensure brevity in your answer.  1.07. What is the ratio of the Emissions (1000 metric ton of CO2 equivalent) in Pakistan in 2005 to that in 2008?
Your answer should be very brief. 0.93. What is the ratio of the Emissions (1000 metric ton of CO2 equivalent) in Syrian Arab Republic in 2005 to that in 2008?
Offer a very short reply. 0.8. What is the ratio of the Emissions (1000 metric ton of CO2 equivalent) of Jordan in 2005 to that in 2010?
Offer a terse response. 0.99. What is the ratio of the Emissions (1000 metric ton of CO2 equivalent) in Latvia in 2005 to that in 2010?
Provide a short and direct response. 1.14. What is the ratio of the Emissions (1000 metric ton of CO2 equivalent) in Pakistan in 2005 to that in 2010?
Offer a very short reply. 0.92. What is the ratio of the Emissions (1000 metric ton of CO2 equivalent) in Syrian Arab Republic in 2005 to that in 2010?
Provide a succinct answer. 0.91. What is the ratio of the Emissions (1000 metric ton of CO2 equivalent) of Jordan in 2008 to that in 2010?
Offer a terse response. 1.18. What is the ratio of the Emissions (1000 metric ton of CO2 equivalent) in Latvia in 2008 to that in 2010?
Make the answer very short. 1.06. What is the ratio of the Emissions (1000 metric ton of CO2 equivalent) of Pakistan in 2008 to that in 2010?
Give a very brief answer. 0.99. What is the ratio of the Emissions (1000 metric ton of CO2 equivalent) in Syrian Arab Republic in 2008 to that in 2010?
Give a very brief answer. 1.14. What is the difference between the highest and the second highest Emissions (1000 metric ton of CO2 equivalent) of Jordan?
Give a very brief answer. 72.8. What is the difference between the highest and the second highest Emissions (1000 metric ton of CO2 equivalent) in Latvia?
Offer a terse response. 2387.1. What is the difference between the highest and the second highest Emissions (1000 metric ton of CO2 equivalent) of Pakistan?
Your answer should be compact. 1082. What is the difference between the highest and the second highest Emissions (1000 metric ton of CO2 equivalent) in Syrian Arab Republic?
Keep it short and to the point. 537. What is the difference between the highest and the lowest Emissions (1000 metric ton of CO2 equivalent) of Jordan?
Make the answer very short. 167.1. What is the difference between the highest and the lowest Emissions (1000 metric ton of CO2 equivalent) in Latvia?
Make the answer very short. 2491.9. What is the difference between the highest and the lowest Emissions (1000 metric ton of CO2 equivalent) in Pakistan?
Provide a short and direct response. 3.04e+04. What is the difference between the highest and the lowest Emissions (1000 metric ton of CO2 equivalent) of Syrian Arab Republic?
Give a very brief answer. 1825.1. 